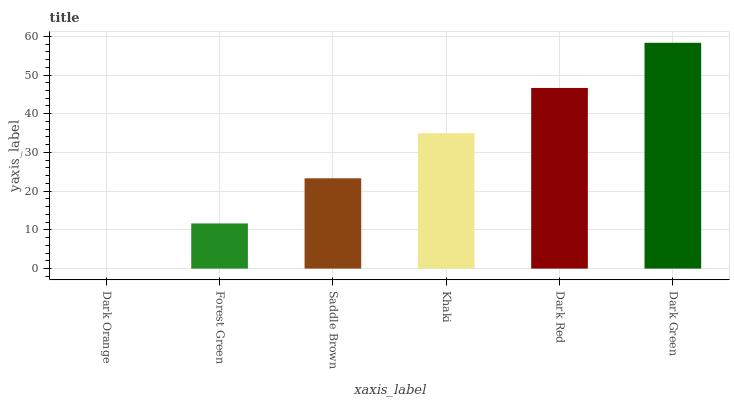Is Dark Orange the minimum?
Answer yes or no. Yes. Is Dark Green the maximum?
Answer yes or no. Yes. Is Forest Green the minimum?
Answer yes or no. No. Is Forest Green the maximum?
Answer yes or no. No. Is Forest Green greater than Dark Orange?
Answer yes or no. Yes. Is Dark Orange less than Forest Green?
Answer yes or no. Yes. Is Dark Orange greater than Forest Green?
Answer yes or no. No. Is Forest Green less than Dark Orange?
Answer yes or no. No. Is Khaki the high median?
Answer yes or no. Yes. Is Saddle Brown the low median?
Answer yes or no. Yes. Is Forest Green the high median?
Answer yes or no. No. Is Dark Orange the low median?
Answer yes or no. No. 